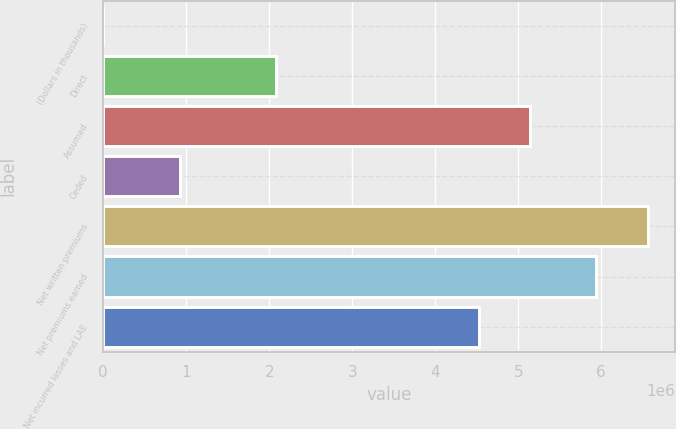Convert chart. <chart><loc_0><loc_0><loc_500><loc_500><bar_chart><fcel>(Dollars in thousands)<fcel>Direct<fcel>Assumed<fcel>Ceded<fcel>Net written premiums<fcel>Net premiums earned<fcel>Net incurred losses and LAE<nl><fcel>2017<fcel>2.08356e+06<fcel>5.14685e+06<fcel>929261<fcel>6.5621e+06<fcel>5.93784e+06<fcel>4.52258e+06<nl></chart> 